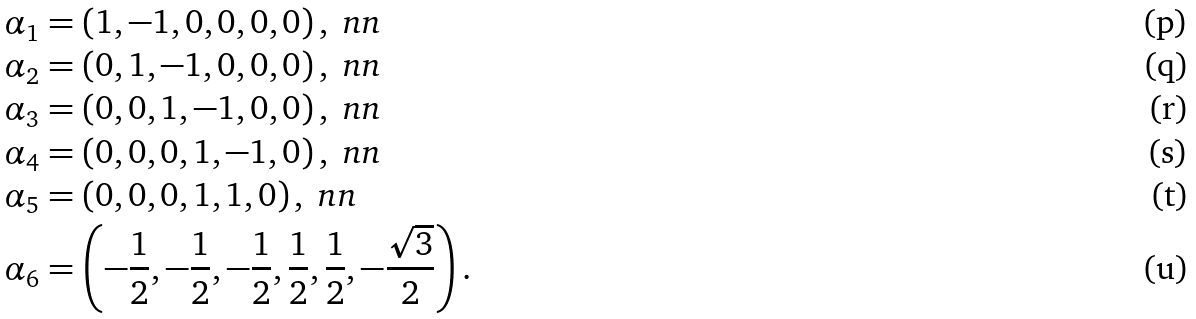<formula> <loc_0><loc_0><loc_500><loc_500>\alpha _ { 1 } & = \left ( 1 , - 1 , 0 , 0 , 0 , 0 \right ) , \ n n \\ \alpha _ { 2 } & = \left ( 0 , 1 , - 1 , 0 , 0 , 0 \right ) , \ n n \\ \alpha _ { 3 } & = \left ( 0 , 0 , 1 , - 1 , 0 , 0 \right ) , \ n n \\ \alpha _ { 4 } & = \left ( 0 , 0 , 0 , 1 , - 1 , 0 \right ) , \ n n \\ \alpha _ { 5 } & = \left ( 0 , 0 , 0 , 1 , 1 , 0 \right ) , \ n n \\ \alpha _ { 6 } & = \left ( - \frac { 1 } { 2 } , - \frac { 1 } { 2 } , - \frac { 1 } { 2 } , \frac { 1 } { 2 } , \frac { 1 } { 2 } , - \frac { \sqrt { 3 } } { 2 } \right ) .</formula> 